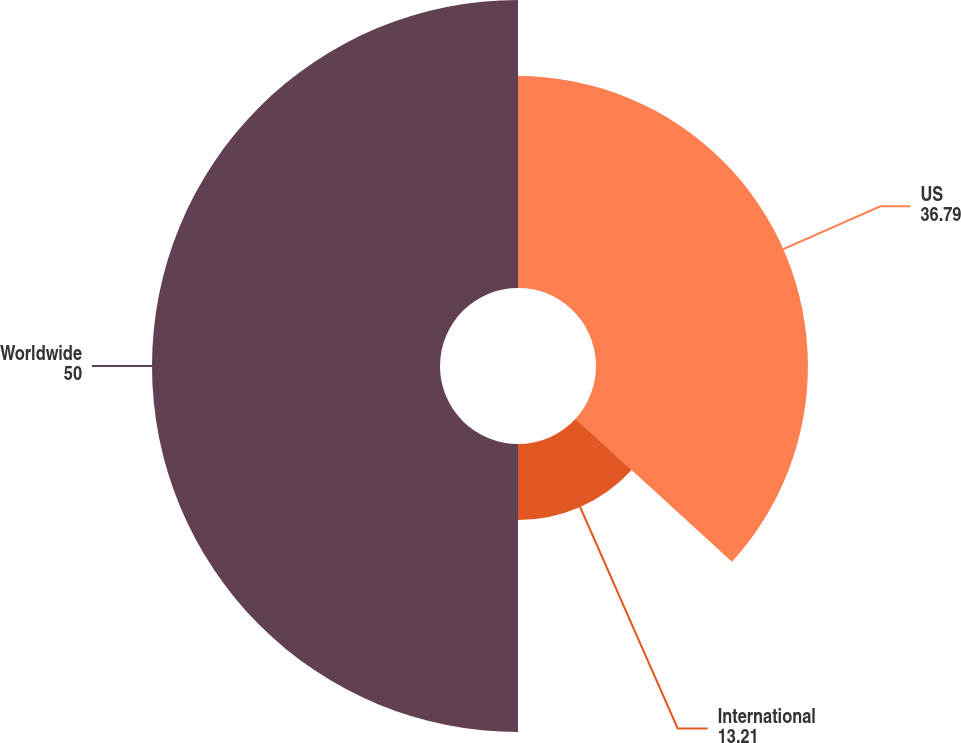Convert chart to OTSL. <chart><loc_0><loc_0><loc_500><loc_500><pie_chart><fcel>US<fcel>International<fcel>Worldwide<nl><fcel>36.79%<fcel>13.21%<fcel>50.0%<nl></chart> 